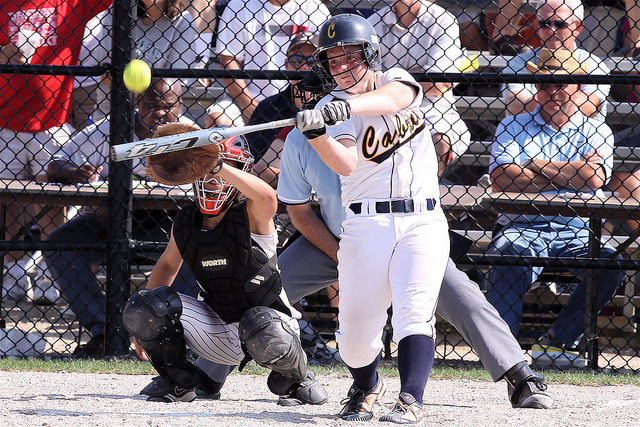Can you tell if this is an outdoor game or an indoor game? This is an outdoor game. The background shows clear skies and natural lighting, indicating that the game is taking place outside. 